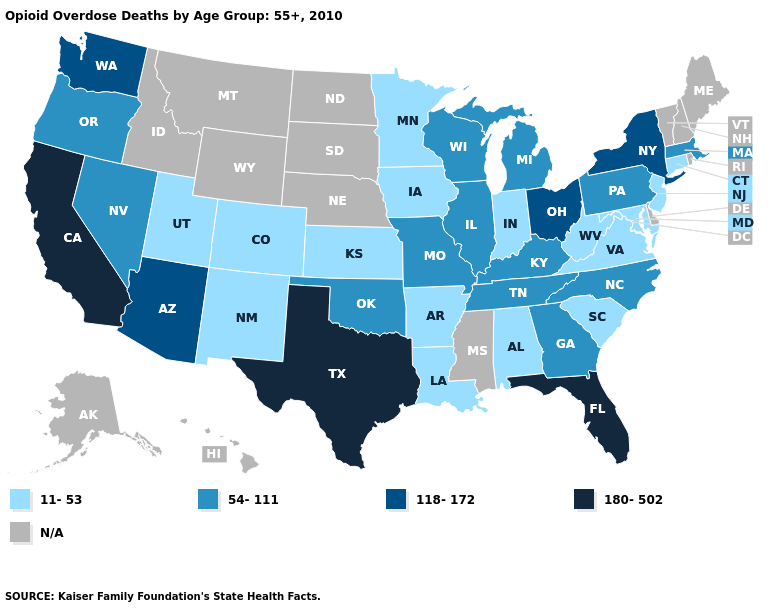Does Georgia have the highest value in the USA?
Keep it brief. No. What is the value of Massachusetts?
Concise answer only. 54-111. Is the legend a continuous bar?
Quick response, please. No. Which states have the highest value in the USA?
Answer briefly. California, Florida, Texas. Name the states that have a value in the range 118-172?
Keep it brief. Arizona, New York, Ohio, Washington. Name the states that have a value in the range 118-172?
Write a very short answer. Arizona, New York, Ohio, Washington. Name the states that have a value in the range 180-502?
Write a very short answer. California, Florida, Texas. What is the highest value in the USA?
Keep it brief. 180-502. What is the value of Connecticut?
Short answer required. 11-53. Name the states that have a value in the range 180-502?
Give a very brief answer. California, Florida, Texas. Name the states that have a value in the range 11-53?
Give a very brief answer. Alabama, Arkansas, Colorado, Connecticut, Indiana, Iowa, Kansas, Louisiana, Maryland, Minnesota, New Jersey, New Mexico, South Carolina, Utah, Virginia, West Virginia. Does Ohio have the highest value in the MidWest?
Short answer required. Yes. Which states hav the highest value in the Northeast?
Quick response, please. New York. Which states have the lowest value in the South?
Answer briefly. Alabama, Arkansas, Louisiana, Maryland, South Carolina, Virginia, West Virginia. What is the value of Delaware?
Quick response, please. N/A. 